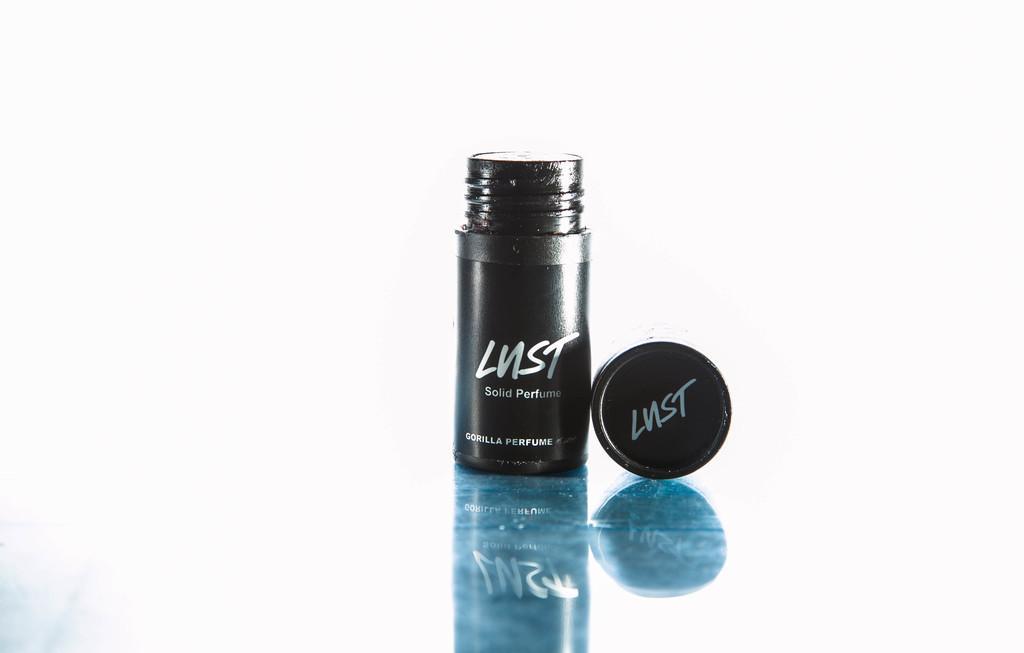Please provide a concise description of this image. There is a perfume placed on the table by opening its cap,the bottle of the perfume is in black color. 